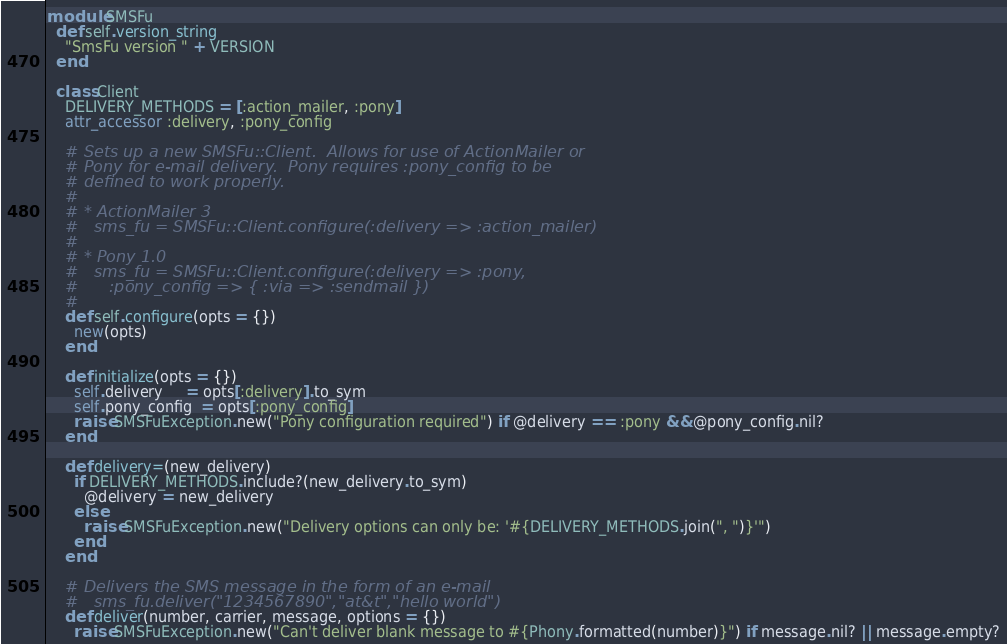<code> <loc_0><loc_0><loc_500><loc_500><_Ruby_>module SMSFu
  def self.version_string
    "SmsFu version " + VERSION
  end
  
  class Client
    DELIVERY_METHODS = [:action_mailer, :pony]
    attr_accessor :delivery, :pony_config

    # Sets up a new SMSFu::Client.  Allows for use of ActionMailer or
    # Pony for e-mail delivery.  Pony requires :pony_config to be 
    # defined to work properly.
    # 
    # * ActionMailer 3
    #   sms_fu = SMSFu::Client.configure(:delivery => :action_mailer)
    #
    # * Pony 1.0
    #   sms_fu = SMSFu::Client.configure(:delivery => :pony, 
    #      :pony_config => { :via => :sendmail })
    #
    def self.configure(opts = {})
      new(opts)
    end
    
    def initialize(opts = {})
      self.delivery     = opts[:delivery].to_sym
      self.pony_config  = opts[:pony_config]
      raise SMSFuException.new("Pony configuration required") if @delivery == :pony && @pony_config.nil?
    end

    def delivery=(new_delivery)
      if DELIVERY_METHODS.include?(new_delivery.to_sym)
        @delivery = new_delivery
      else
        raise SMSFuException.new("Delivery options can only be: '#{DELIVERY_METHODS.join(", ")}'")
      end
    end

    # Delivers the SMS message in the form of an e-mail
    #   sms_fu.deliver("1234567890","at&t","hello world")
    def deliver(number, carrier, message, options = {})
      raise SMSFuException.new("Can't deliver blank message to #{Phony.formatted(number)}") if message.nil? || message.empty?
</code> 